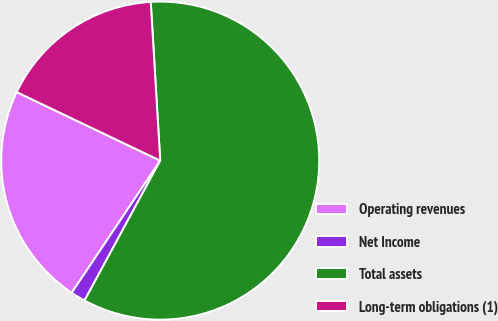Convert chart. <chart><loc_0><loc_0><loc_500><loc_500><pie_chart><fcel>Operating revenues<fcel>Net Income<fcel>Total assets<fcel>Long-term obligations (1)<nl><fcel>22.7%<fcel>1.5%<fcel>58.84%<fcel>16.96%<nl></chart> 